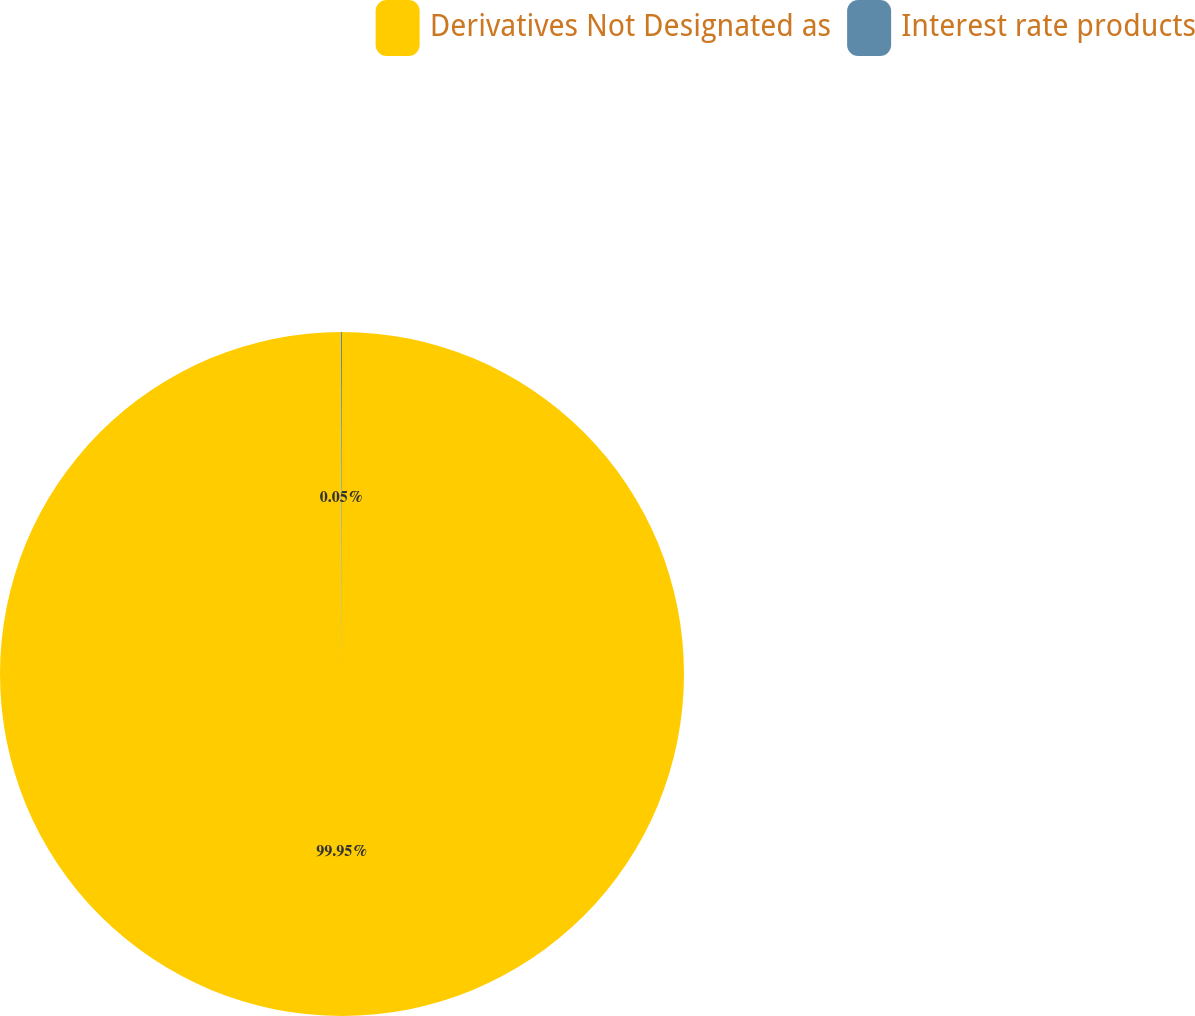Convert chart to OTSL. <chart><loc_0><loc_0><loc_500><loc_500><pie_chart><fcel>Derivatives Not Designated as<fcel>Interest rate products<nl><fcel>99.95%<fcel>0.05%<nl></chart> 